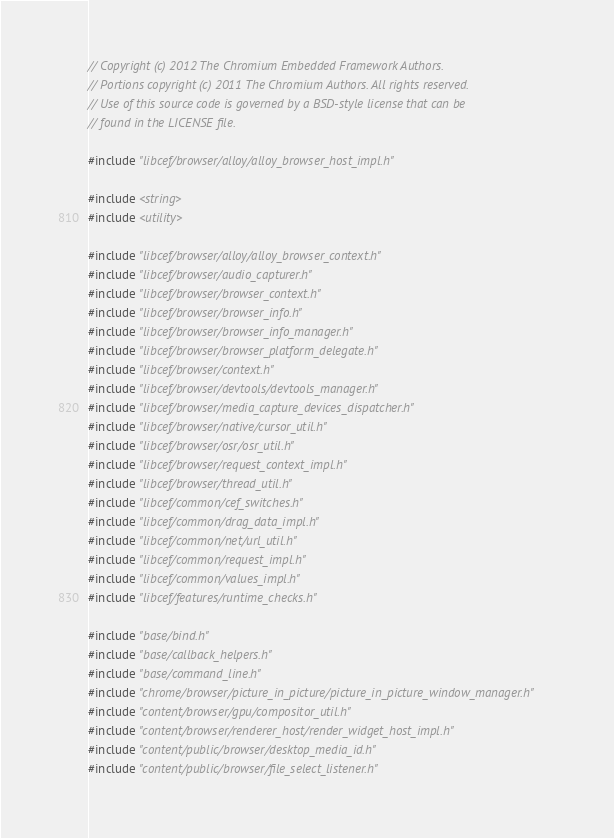Convert code to text. <code><loc_0><loc_0><loc_500><loc_500><_C++_>// Copyright (c) 2012 The Chromium Embedded Framework Authors.
// Portions copyright (c) 2011 The Chromium Authors. All rights reserved.
// Use of this source code is governed by a BSD-style license that can be
// found in the LICENSE file.

#include "libcef/browser/alloy/alloy_browser_host_impl.h"

#include <string>
#include <utility>

#include "libcef/browser/alloy/alloy_browser_context.h"
#include "libcef/browser/audio_capturer.h"
#include "libcef/browser/browser_context.h"
#include "libcef/browser/browser_info.h"
#include "libcef/browser/browser_info_manager.h"
#include "libcef/browser/browser_platform_delegate.h"
#include "libcef/browser/context.h"
#include "libcef/browser/devtools/devtools_manager.h"
#include "libcef/browser/media_capture_devices_dispatcher.h"
#include "libcef/browser/native/cursor_util.h"
#include "libcef/browser/osr/osr_util.h"
#include "libcef/browser/request_context_impl.h"
#include "libcef/browser/thread_util.h"
#include "libcef/common/cef_switches.h"
#include "libcef/common/drag_data_impl.h"
#include "libcef/common/net/url_util.h"
#include "libcef/common/request_impl.h"
#include "libcef/common/values_impl.h"
#include "libcef/features/runtime_checks.h"

#include "base/bind.h"
#include "base/callback_helpers.h"
#include "base/command_line.h"
#include "chrome/browser/picture_in_picture/picture_in_picture_window_manager.h"
#include "content/browser/gpu/compositor_util.h"
#include "content/browser/renderer_host/render_widget_host_impl.h"
#include "content/public/browser/desktop_media_id.h"
#include "content/public/browser/file_select_listener.h"</code> 